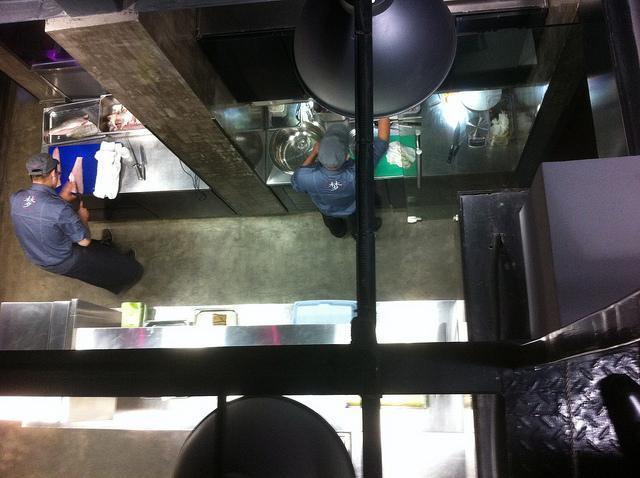How many people are in the photo?
Give a very brief answer. 2. How many people are between the two orange buses in the image?
Give a very brief answer. 0. 